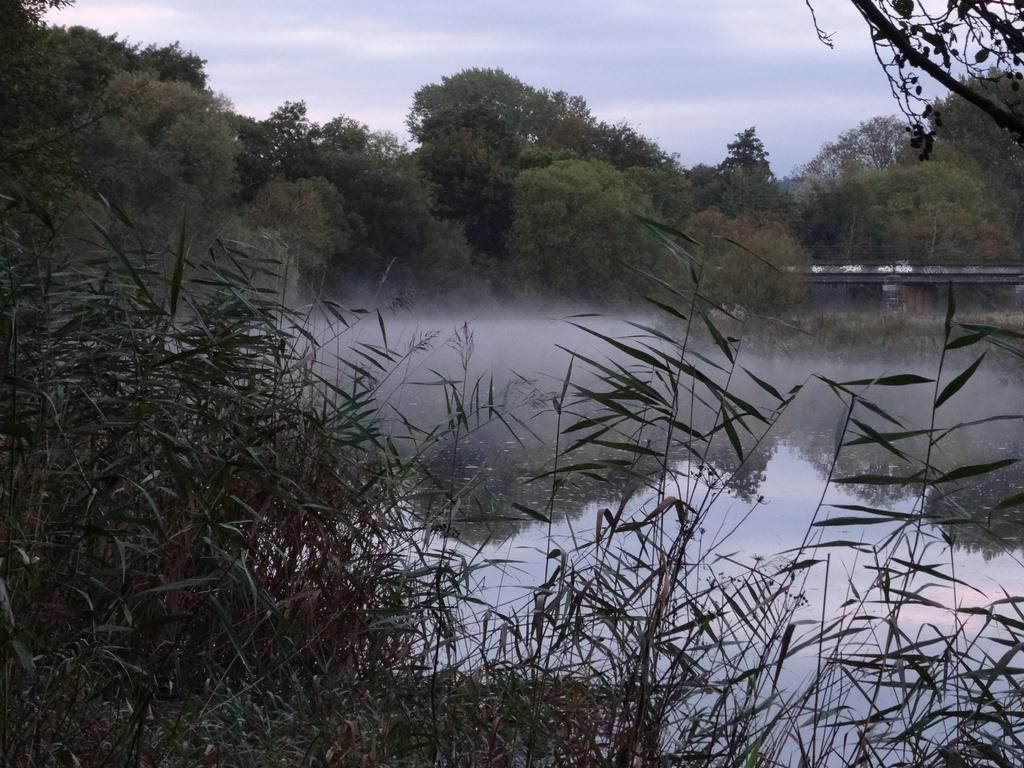What type of vegetation can be seen in the image? There are trees in the image. What natural element is also present in the image? There is water in the image. What structure can be seen crossing over the water? There is a bridge in the image. What is visible at the top of the image? The sky is visible at the top of the image. What type of plants are present at the bottom of the image? Plants are present at the bottom of the image. Where is the glove located in the image? There is no glove present in the image. What type of rod can be seen in the image? There is no rod present in the image. 